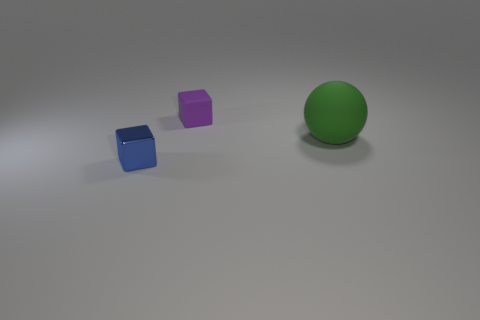Does the tiny rubber cube have the same color as the small shiny cube?
Give a very brief answer. No. Does the cube in front of the big green rubber sphere have the same material as the thing behind the big green object?
Keep it short and to the point. No. Is the number of big purple metal cubes greater than the number of green matte objects?
Ensure brevity in your answer.  No. Is there anything else that has the same color as the small matte object?
Keep it short and to the point. No. Are the purple block and the tiny blue cube made of the same material?
Provide a succinct answer. No. Is the number of tiny green spheres less than the number of large things?
Your answer should be compact. Yes. Does the tiny blue metallic thing have the same shape as the green matte object?
Offer a very short reply. No. The big matte sphere is what color?
Keep it short and to the point. Green. How many other things are made of the same material as the blue object?
Provide a short and direct response. 0. How many blue things are either small rubber cubes or metallic objects?
Offer a terse response. 1. 